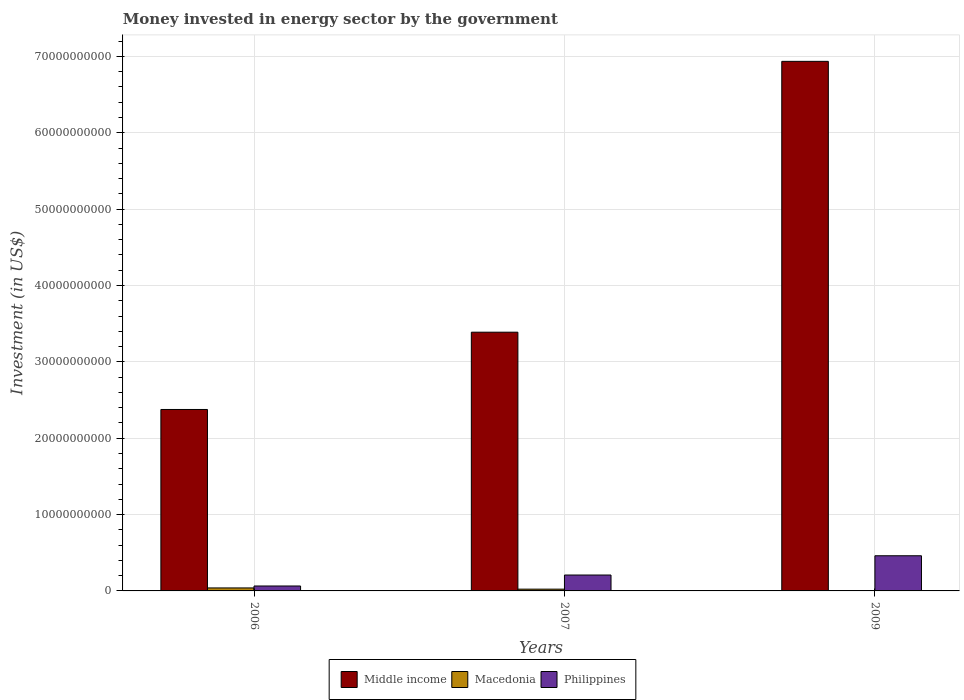How many different coloured bars are there?
Your response must be concise. 3. Are the number of bars per tick equal to the number of legend labels?
Your answer should be compact. Yes. Are the number of bars on each tick of the X-axis equal?
Give a very brief answer. Yes. How many bars are there on the 3rd tick from the left?
Provide a short and direct response. 3. How many bars are there on the 2nd tick from the right?
Make the answer very short. 3. What is the money spent in energy sector in Philippines in 2006?
Give a very brief answer. 6.46e+08. Across all years, what is the maximum money spent in energy sector in Macedonia?
Your answer should be compact. 3.91e+08. Across all years, what is the minimum money spent in energy sector in Philippines?
Your answer should be compact. 6.46e+08. In which year was the money spent in energy sector in Middle income minimum?
Your answer should be compact. 2006. What is the total money spent in energy sector in Macedonia in the graph?
Offer a very short reply. 6.55e+08. What is the difference between the money spent in energy sector in Middle income in 2007 and that in 2009?
Your answer should be compact. -3.55e+1. What is the difference between the money spent in energy sector in Middle income in 2007 and the money spent in energy sector in Macedonia in 2009?
Offer a very short reply. 3.39e+1. What is the average money spent in energy sector in Middle income per year?
Ensure brevity in your answer.  4.23e+1. In the year 2007, what is the difference between the money spent in energy sector in Macedonia and money spent in energy sector in Philippines?
Provide a succinct answer. -1.85e+09. What is the ratio of the money spent in energy sector in Macedonia in 2007 to that in 2009?
Offer a terse response. 7.52. Is the money spent in energy sector in Philippines in 2006 less than that in 2009?
Make the answer very short. Yes. Is the difference between the money spent in energy sector in Macedonia in 2007 and 2009 greater than the difference between the money spent in energy sector in Philippines in 2007 and 2009?
Your response must be concise. Yes. What is the difference between the highest and the second highest money spent in energy sector in Macedonia?
Make the answer very short. 1.58e+08. What is the difference between the highest and the lowest money spent in energy sector in Middle income?
Your response must be concise. 4.56e+1. What does the 3rd bar from the left in 2006 represents?
Keep it short and to the point. Philippines. What does the 3rd bar from the right in 2009 represents?
Make the answer very short. Middle income. Is it the case that in every year, the sum of the money spent in energy sector in Philippines and money spent in energy sector in Macedonia is greater than the money spent in energy sector in Middle income?
Give a very brief answer. No. Does the graph contain grids?
Your response must be concise. Yes. Where does the legend appear in the graph?
Offer a very short reply. Bottom center. How many legend labels are there?
Provide a short and direct response. 3. What is the title of the graph?
Ensure brevity in your answer.  Money invested in energy sector by the government. What is the label or title of the Y-axis?
Offer a terse response. Investment (in US$). What is the Investment (in US$) in Middle income in 2006?
Keep it short and to the point. 2.38e+1. What is the Investment (in US$) of Macedonia in 2006?
Provide a short and direct response. 3.91e+08. What is the Investment (in US$) of Philippines in 2006?
Offer a very short reply. 6.46e+08. What is the Investment (in US$) of Middle income in 2007?
Offer a very short reply. 3.39e+1. What is the Investment (in US$) in Macedonia in 2007?
Provide a succinct answer. 2.33e+08. What is the Investment (in US$) of Philippines in 2007?
Offer a very short reply. 2.08e+09. What is the Investment (in US$) in Middle income in 2009?
Make the answer very short. 6.94e+1. What is the Investment (in US$) in Macedonia in 2009?
Your response must be concise. 3.10e+07. What is the Investment (in US$) of Philippines in 2009?
Provide a short and direct response. 4.60e+09. Across all years, what is the maximum Investment (in US$) of Middle income?
Your answer should be compact. 6.94e+1. Across all years, what is the maximum Investment (in US$) of Macedonia?
Your answer should be compact. 3.91e+08. Across all years, what is the maximum Investment (in US$) in Philippines?
Your answer should be compact. 4.60e+09. Across all years, what is the minimum Investment (in US$) of Middle income?
Ensure brevity in your answer.  2.38e+1. Across all years, what is the minimum Investment (in US$) of Macedonia?
Offer a terse response. 3.10e+07. Across all years, what is the minimum Investment (in US$) in Philippines?
Your answer should be compact. 6.46e+08. What is the total Investment (in US$) of Middle income in the graph?
Provide a succinct answer. 1.27e+11. What is the total Investment (in US$) in Macedonia in the graph?
Give a very brief answer. 6.55e+08. What is the total Investment (in US$) in Philippines in the graph?
Make the answer very short. 7.33e+09. What is the difference between the Investment (in US$) of Middle income in 2006 and that in 2007?
Your answer should be very brief. -1.01e+1. What is the difference between the Investment (in US$) of Macedonia in 2006 and that in 2007?
Your response must be concise. 1.58e+08. What is the difference between the Investment (in US$) in Philippines in 2006 and that in 2007?
Offer a very short reply. -1.44e+09. What is the difference between the Investment (in US$) of Middle income in 2006 and that in 2009?
Provide a short and direct response. -4.56e+1. What is the difference between the Investment (in US$) of Macedonia in 2006 and that in 2009?
Ensure brevity in your answer.  3.60e+08. What is the difference between the Investment (in US$) in Philippines in 2006 and that in 2009?
Your answer should be compact. -3.96e+09. What is the difference between the Investment (in US$) in Middle income in 2007 and that in 2009?
Keep it short and to the point. -3.55e+1. What is the difference between the Investment (in US$) in Macedonia in 2007 and that in 2009?
Ensure brevity in your answer.  2.02e+08. What is the difference between the Investment (in US$) in Philippines in 2007 and that in 2009?
Your answer should be very brief. -2.52e+09. What is the difference between the Investment (in US$) in Middle income in 2006 and the Investment (in US$) in Macedonia in 2007?
Offer a terse response. 2.35e+1. What is the difference between the Investment (in US$) in Middle income in 2006 and the Investment (in US$) in Philippines in 2007?
Offer a very short reply. 2.17e+1. What is the difference between the Investment (in US$) in Macedonia in 2006 and the Investment (in US$) in Philippines in 2007?
Your answer should be very brief. -1.69e+09. What is the difference between the Investment (in US$) in Middle income in 2006 and the Investment (in US$) in Macedonia in 2009?
Keep it short and to the point. 2.37e+1. What is the difference between the Investment (in US$) in Middle income in 2006 and the Investment (in US$) in Philippines in 2009?
Keep it short and to the point. 1.92e+1. What is the difference between the Investment (in US$) of Macedonia in 2006 and the Investment (in US$) of Philippines in 2009?
Offer a very short reply. -4.21e+09. What is the difference between the Investment (in US$) of Middle income in 2007 and the Investment (in US$) of Macedonia in 2009?
Your answer should be very brief. 3.39e+1. What is the difference between the Investment (in US$) of Middle income in 2007 and the Investment (in US$) of Philippines in 2009?
Provide a short and direct response. 2.93e+1. What is the difference between the Investment (in US$) of Macedonia in 2007 and the Investment (in US$) of Philippines in 2009?
Offer a very short reply. -4.37e+09. What is the average Investment (in US$) in Middle income per year?
Give a very brief answer. 4.23e+1. What is the average Investment (in US$) of Macedonia per year?
Offer a terse response. 2.18e+08. What is the average Investment (in US$) in Philippines per year?
Offer a terse response. 2.44e+09. In the year 2006, what is the difference between the Investment (in US$) of Middle income and Investment (in US$) of Macedonia?
Your response must be concise. 2.34e+1. In the year 2006, what is the difference between the Investment (in US$) of Middle income and Investment (in US$) of Philippines?
Your answer should be very brief. 2.31e+1. In the year 2006, what is the difference between the Investment (in US$) of Macedonia and Investment (in US$) of Philippines?
Make the answer very short. -2.55e+08. In the year 2007, what is the difference between the Investment (in US$) of Middle income and Investment (in US$) of Macedonia?
Ensure brevity in your answer.  3.37e+1. In the year 2007, what is the difference between the Investment (in US$) of Middle income and Investment (in US$) of Philippines?
Provide a short and direct response. 3.18e+1. In the year 2007, what is the difference between the Investment (in US$) of Macedonia and Investment (in US$) of Philippines?
Keep it short and to the point. -1.85e+09. In the year 2009, what is the difference between the Investment (in US$) of Middle income and Investment (in US$) of Macedonia?
Make the answer very short. 6.93e+1. In the year 2009, what is the difference between the Investment (in US$) of Middle income and Investment (in US$) of Philippines?
Make the answer very short. 6.47e+1. In the year 2009, what is the difference between the Investment (in US$) of Macedonia and Investment (in US$) of Philippines?
Provide a short and direct response. -4.57e+09. What is the ratio of the Investment (in US$) of Middle income in 2006 to that in 2007?
Offer a terse response. 0.7. What is the ratio of the Investment (in US$) in Macedonia in 2006 to that in 2007?
Ensure brevity in your answer.  1.68. What is the ratio of the Investment (in US$) of Philippines in 2006 to that in 2007?
Your answer should be compact. 0.31. What is the ratio of the Investment (in US$) of Middle income in 2006 to that in 2009?
Ensure brevity in your answer.  0.34. What is the ratio of the Investment (in US$) of Macedonia in 2006 to that in 2009?
Your response must be concise. 12.61. What is the ratio of the Investment (in US$) of Philippines in 2006 to that in 2009?
Offer a very short reply. 0.14. What is the ratio of the Investment (in US$) of Middle income in 2007 to that in 2009?
Give a very brief answer. 0.49. What is the ratio of the Investment (in US$) of Macedonia in 2007 to that in 2009?
Make the answer very short. 7.52. What is the ratio of the Investment (in US$) in Philippines in 2007 to that in 2009?
Give a very brief answer. 0.45. What is the difference between the highest and the second highest Investment (in US$) in Middle income?
Provide a short and direct response. 3.55e+1. What is the difference between the highest and the second highest Investment (in US$) of Macedonia?
Your answer should be very brief. 1.58e+08. What is the difference between the highest and the second highest Investment (in US$) in Philippines?
Give a very brief answer. 2.52e+09. What is the difference between the highest and the lowest Investment (in US$) of Middle income?
Ensure brevity in your answer.  4.56e+1. What is the difference between the highest and the lowest Investment (in US$) of Macedonia?
Provide a succinct answer. 3.60e+08. What is the difference between the highest and the lowest Investment (in US$) in Philippines?
Provide a succinct answer. 3.96e+09. 